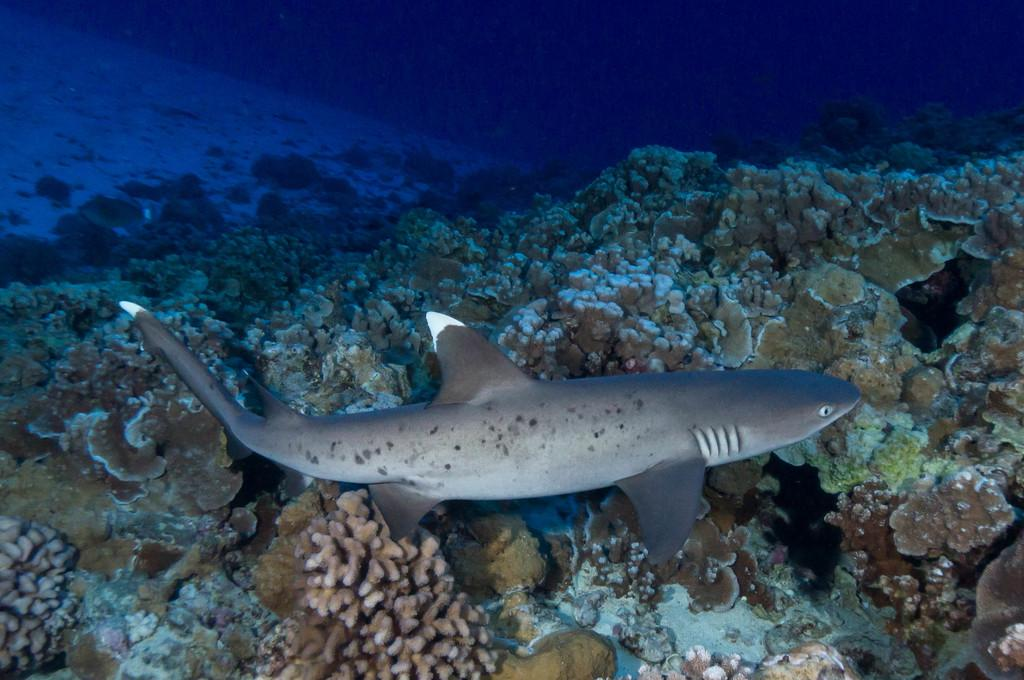What type of natural formation can be seen in the image? There are corals in the image. What other living organism is present in the image? There is a sea animal in the image. Where are the corals and sea animal located? The corals and sea animal are in the water. What is the lawyer's role in the image? There is no lawyer present in the image, as it features corals and a sea animal in the water. 